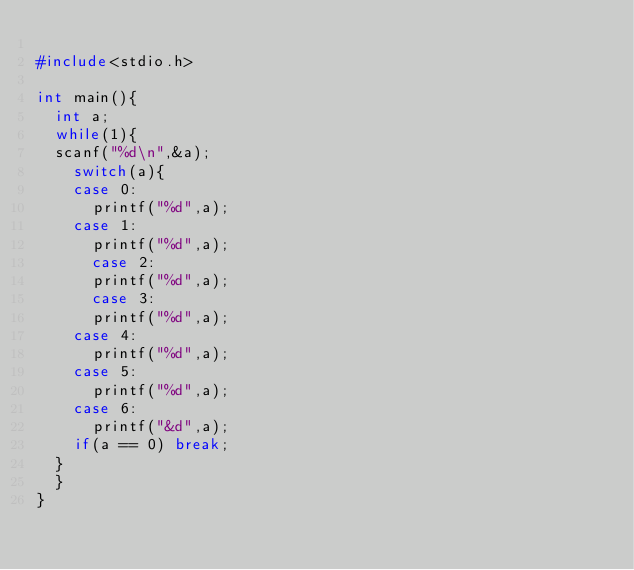Convert code to text. <code><loc_0><loc_0><loc_500><loc_500><_C_>
#include<stdio.h>

int main(){
	int a;
	while(1){
	scanf("%d\n",&a);
	  switch(a){
		case 0:
		  printf("%d",a);
		case 1:
		  printf("%d",a);
	    case 2:
		  printf("%d",a);
	    case 3:
		  printf("%d",a);
		case 4:
		  printf("%d",a);
		case 5:
		  printf("%d",a);
		case 6:
		  printf("&d",a);
		if(a == 0) break;
	}
  }
}</code> 